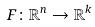Convert formula to latex. <formula><loc_0><loc_0><loc_500><loc_500>F \colon \mathbb { R } ^ { n } \rightarrow \mathbb { R } ^ { k }</formula> 